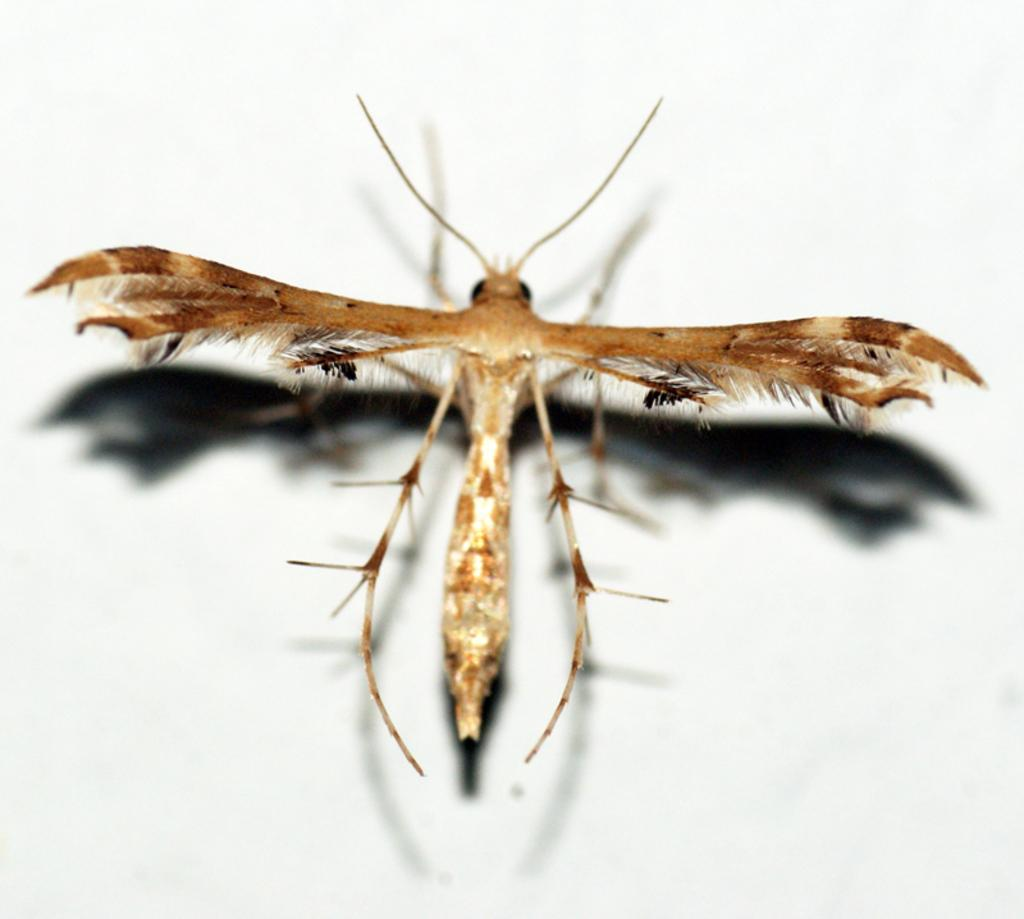What type of creature is in the picture? There is an insect in the picture. What are the main features of the insect? The insect has wings and a long antenna. Where is the insect located in the image? The insect is standing on a wall. What colors can be seen on the insect? The insect is brown in color and has white shades on it. What type of apparatus is the insect using to climb the wall? There is no apparatus present in the image; the insect is standing on the wall without any visible assistance. 